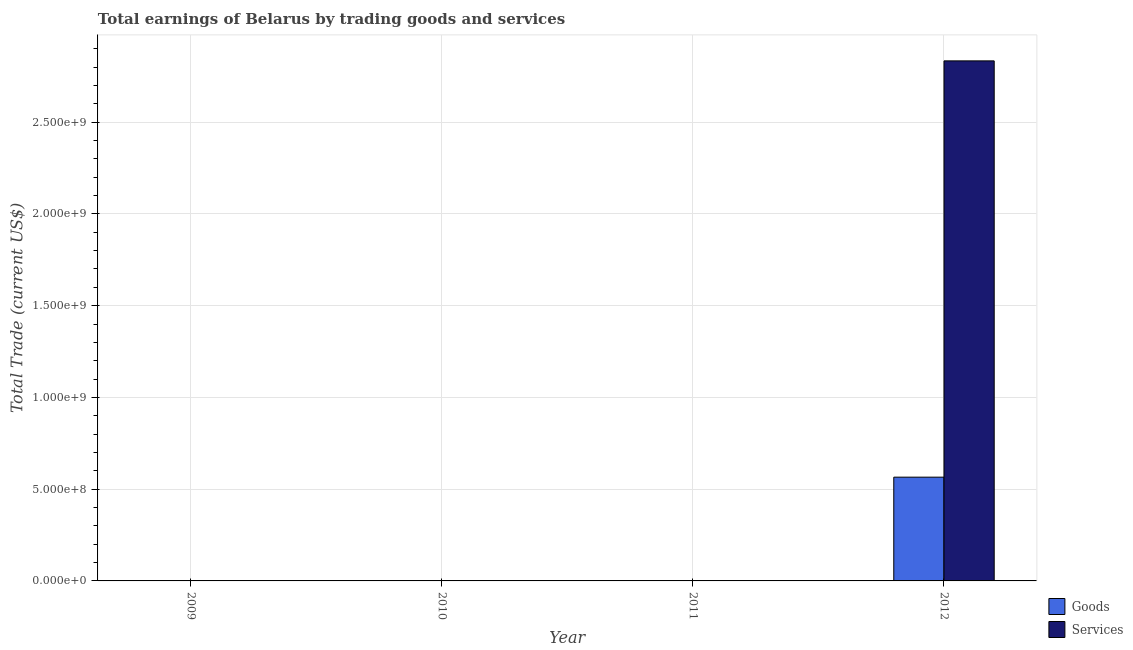How many bars are there on the 4th tick from the left?
Keep it short and to the point. 2. In how many cases, is the number of bars for a given year not equal to the number of legend labels?
Make the answer very short. 3. What is the amount earned by trading goods in 2012?
Your response must be concise. 5.65e+08. Across all years, what is the maximum amount earned by trading goods?
Your answer should be very brief. 5.65e+08. In which year was the amount earned by trading goods maximum?
Your answer should be compact. 2012. What is the total amount earned by trading services in the graph?
Make the answer very short. 2.83e+09. What is the difference between the amount earned by trading services in 2012 and the amount earned by trading goods in 2010?
Keep it short and to the point. 2.83e+09. What is the average amount earned by trading services per year?
Give a very brief answer. 7.08e+08. In how many years, is the amount earned by trading goods greater than 1300000000 US$?
Provide a short and direct response. 0. What is the difference between the highest and the lowest amount earned by trading goods?
Provide a succinct answer. 5.65e+08. How many bars are there?
Give a very brief answer. 2. Are all the bars in the graph horizontal?
Keep it short and to the point. No. How many years are there in the graph?
Make the answer very short. 4. What is the difference between two consecutive major ticks on the Y-axis?
Provide a short and direct response. 5.00e+08. Are the values on the major ticks of Y-axis written in scientific E-notation?
Keep it short and to the point. Yes. What is the title of the graph?
Your response must be concise. Total earnings of Belarus by trading goods and services. What is the label or title of the X-axis?
Give a very brief answer. Year. What is the label or title of the Y-axis?
Your response must be concise. Total Trade (current US$). What is the Total Trade (current US$) in Services in 2010?
Offer a very short reply. 0. What is the Total Trade (current US$) of Goods in 2012?
Provide a short and direct response. 5.65e+08. What is the Total Trade (current US$) in Services in 2012?
Ensure brevity in your answer.  2.83e+09. Across all years, what is the maximum Total Trade (current US$) of Goods?
Offer a terse response. 5.65e+08. Across all years, what is the maximum Total Trade (current US$) in Services?
Provide a succinct answer. 2.83e+09. Across all years, what is the minimum Total Trade (current US$) of Goods?
Keep it short and to the point. 0. What is the total Total Trade (current US$) in Goods in the graph?
Keep it short and to the point. 5.65e+08. What is the total Total Trade (current US$) of Services in the graph?
Keep it short and to the point. 2.83e+09. What is the average Total Trade (current US$) of Goods per year?
Ensure brevity in your answer.  1.41e+08. What is the average Total Trade (current US$) in Services per year?
Your answer should be very brief. 7.08e+08. In the year 2012, what is the difference between the Total Trade (current US$) of Goods and Total Trade (current US$) of Services?
Your answer should be compact. -2.27e+09. What is the difference between the highest and the lowest Total Trade (current US$) in Goods?
Offer a very short reply. 5.65e+08. What is the difference between the highest and the lowest Total Trade (current US$) of Services?
Offer a terse response. 2.83e+09. 